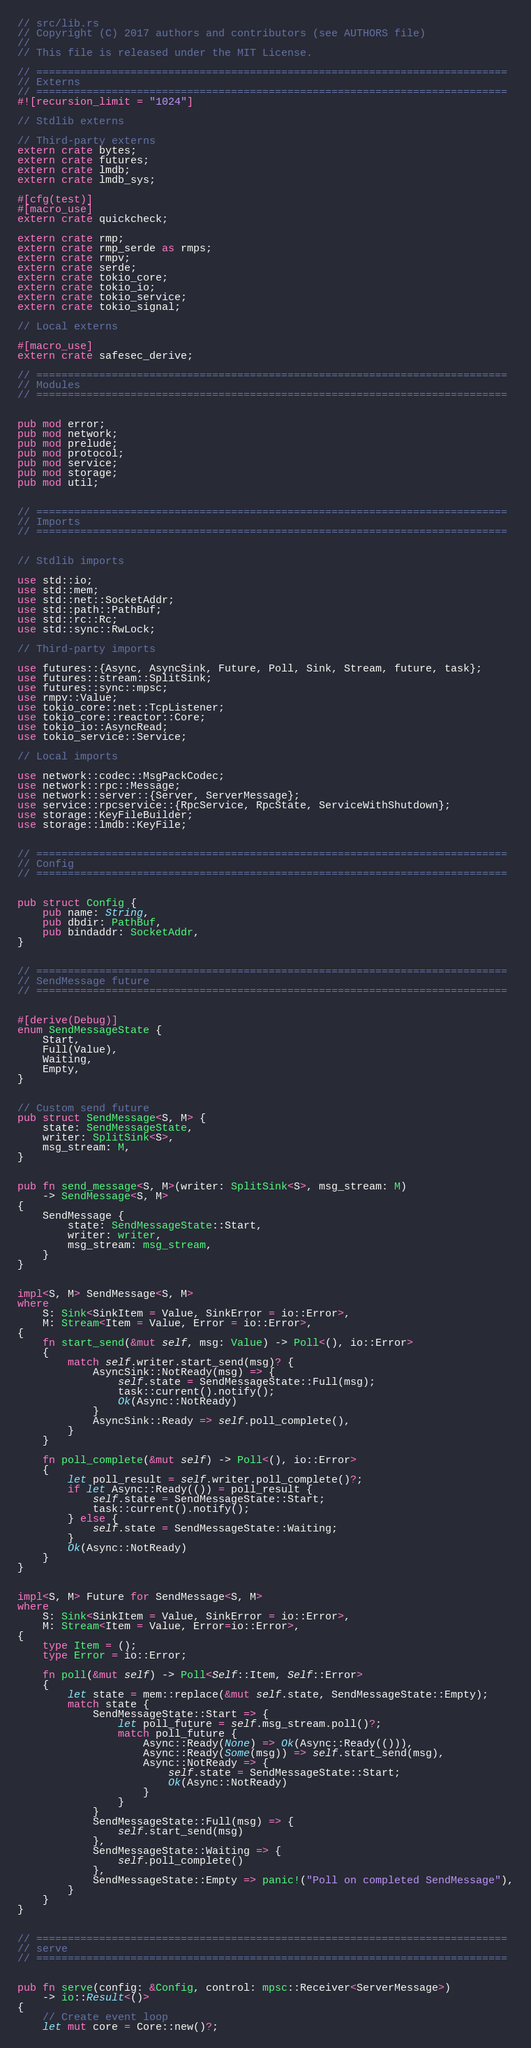Convert code to text. <code><loc_0><loc_0><loc_500><loc_500><_Rust_>// src/lib.rs
// Copyright (C) 2017 authors and contributors (see AUTHORS file)
//
// This file is released under the MIT License.

// ===========================================================================
// Externs
// ===========================================================================
#![recursion_limit = "1024"]

// Stdlib externs

// Third-party externs
extern crate bytes;
extern crate futures;
extern crate lmdb;
extern crate lmdb_sys;

#[cfg(test)]
#[macro_use]
extern crate quickcheck;

extern crate rmp;
extern crate rmp_serde as rmps;
extern crate rmpv;
extern crate serde;
extern crate tokio_core;
extern crate tokio_io;
extern crate tokio_service;
extern crate tokio_signal;

// Local externs

#[macro_use]
extern crate safesec_derive;

// ===========================================================================
// Modules
// ===========================================================================


pub mod error;
pub mod network;
pub mod prelude;
pub mod protocol;
pub mod service;
pub mod storage;
pub mod util;


// ===========================================================================
// Imports
// ===========================================================================


// Stdlib imports

use std::io;
use std::mem;
use std::net::SocketAddr;
use std::path::PathBuf;
use std::rc::Rc;
use std::sync::RwLock;

// Third-party imports

use futures::{Async, AsyncSink, Future, Poll, Sink, Stream, future, task};
use futures::stream::SplitSink;
use futures::sync::mpsc;
use rmpv::Value;
use tokio_core::net::TcpListener;
use tokio_core::reactor::Core;
use tokio_io::AsyncRead;
use tokio_service::Service;

// Local imports

use network::codec::MsgPackCodec;
use network::rpc::Message;
use network::server::{Server, ServerMessage};
use service::rpcservice::{RpcService, RpcState, ServiceWithShutdown};
use storage::KeyFileBuilder;
use storage::lmdb::KeyFile;


// ===========================================================================
// Config
// ===========================================================================


pub struct Config {
    pub name: String,
    pub dbdir: PathBuf,
    pub bindaddr: SocketAddr,
}


// ===========================================================================
// SendMessage future
// ===========================================================================


#[derive(Debug)]
enum SendMessageState {
    Start,
    Full(Value),
    Waiting,
    Empty,
}


// Custom send future
pub struct SendMessage<S, M> {
    state: SendMessageState,
    writer: SplitSink<S>,
    msg_stream: M,
}


pub fn send_message<S, M>(writer: SplitSink<S>, msg_stream: M)
    -> SendMessage<S, M>
{
    SendMessage {
        state: SendMessageState::Start,
        writer: writer,
        msg_stream: msg_stream,
    }
}


impl<S, M> SendMessage<S, M>
where
    S: Sink<SinkItem = Value, SinkError = io::Error>,
    M: Stream<Item = Value, Error = io::Error>,
{
    fn start_send(&mut self, msg: Value) -> Poll<(), io::Error>
    {
        match self.writer.start_send(msg)? {
            AsyncSink::NotReady(msg) => {
                self.state = SendMessageState::Full(msg);
                task::current().notify();
                Ok(Async::NotReady)
            }
            AsyncSink::Ready => self.poll_complete(),
        }
    }

    fn poll_complete(&mut self) -> Poll<(), io::Error>
    {
        let poll_result = self.writer.poll_complete()?;
        if let Async::Ready(()) = poll_result {
            self.state = SendMessageState::Start;
            task::current().notify();
        } else {
            self.state = SendMessageState::Waiting;
        }
        Ok(Async::NotReady)
    }
}


impl<S, M> Future for SendMessage<S, M>
where
    S: Sink<SinkItem = Value, SinkError = io::Error>,
    M: Stream<Item = Value, Error=io::Error>,
{
    type Item = ();
    type Error = io::Error;

    fn poll(&mut self) -> Poll<Self::Item, Self::Error>
    {
        let state = mem::replace(&mut self.state, SendMessageState::Empty);
        match state {
            SendMessageState::Start => {
                let poll_future = self.msg_stream.poll()?;
                match poll_future {
                    Async::Ready(None) => Ok(Async::Ready(())),
                    Async::Ready(Some(msg)) => self.start_send(msg),
                    Async::NotReady => {
                        self.state = SendMessageState::Start;
                        Ok(Async::NotReady)
                    }
                }
            }
            SendMessageState::Full(msg) => {
                self.start_send(msg)
            },
            SendMessageState::Waiting => {
                self.poll_complete()
            },
            SendMessageState::Empty => panic!("Poll on completed SendMessage"),
        }
    }
}


// ===========================================================================
// serve
// ===========================================================================


pub fn serve(config: &Config, control: mpsc::Receiver<ServerMessage>)
    -> io::Result<()>
{
    // Create event loop
    let mut core = Core::new()?;</code> 